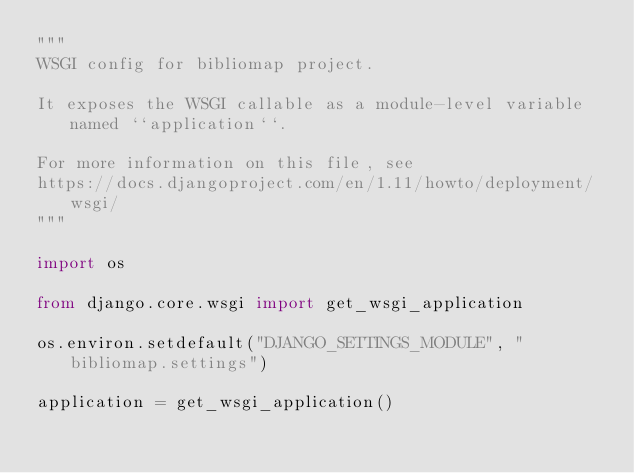Convert code to text. <code><loc_0><loc_0><loc_500><loc_500><_Python_>"""
WSGI config for bibliomap project.

It exposes the WSGI callable as a module-level variable named ``application``.

For more information on this file, see
https://docs.djangoproject.com/en/1.11/howto/deployment/wsgi/
"""

import os

from django.core.wsgi import get_wsgi_application

os.environ.setdefault("DJANGO_SETTINGS_MODULE", "bibliomap.settings")

application = get_wsgi_application()
</code> 